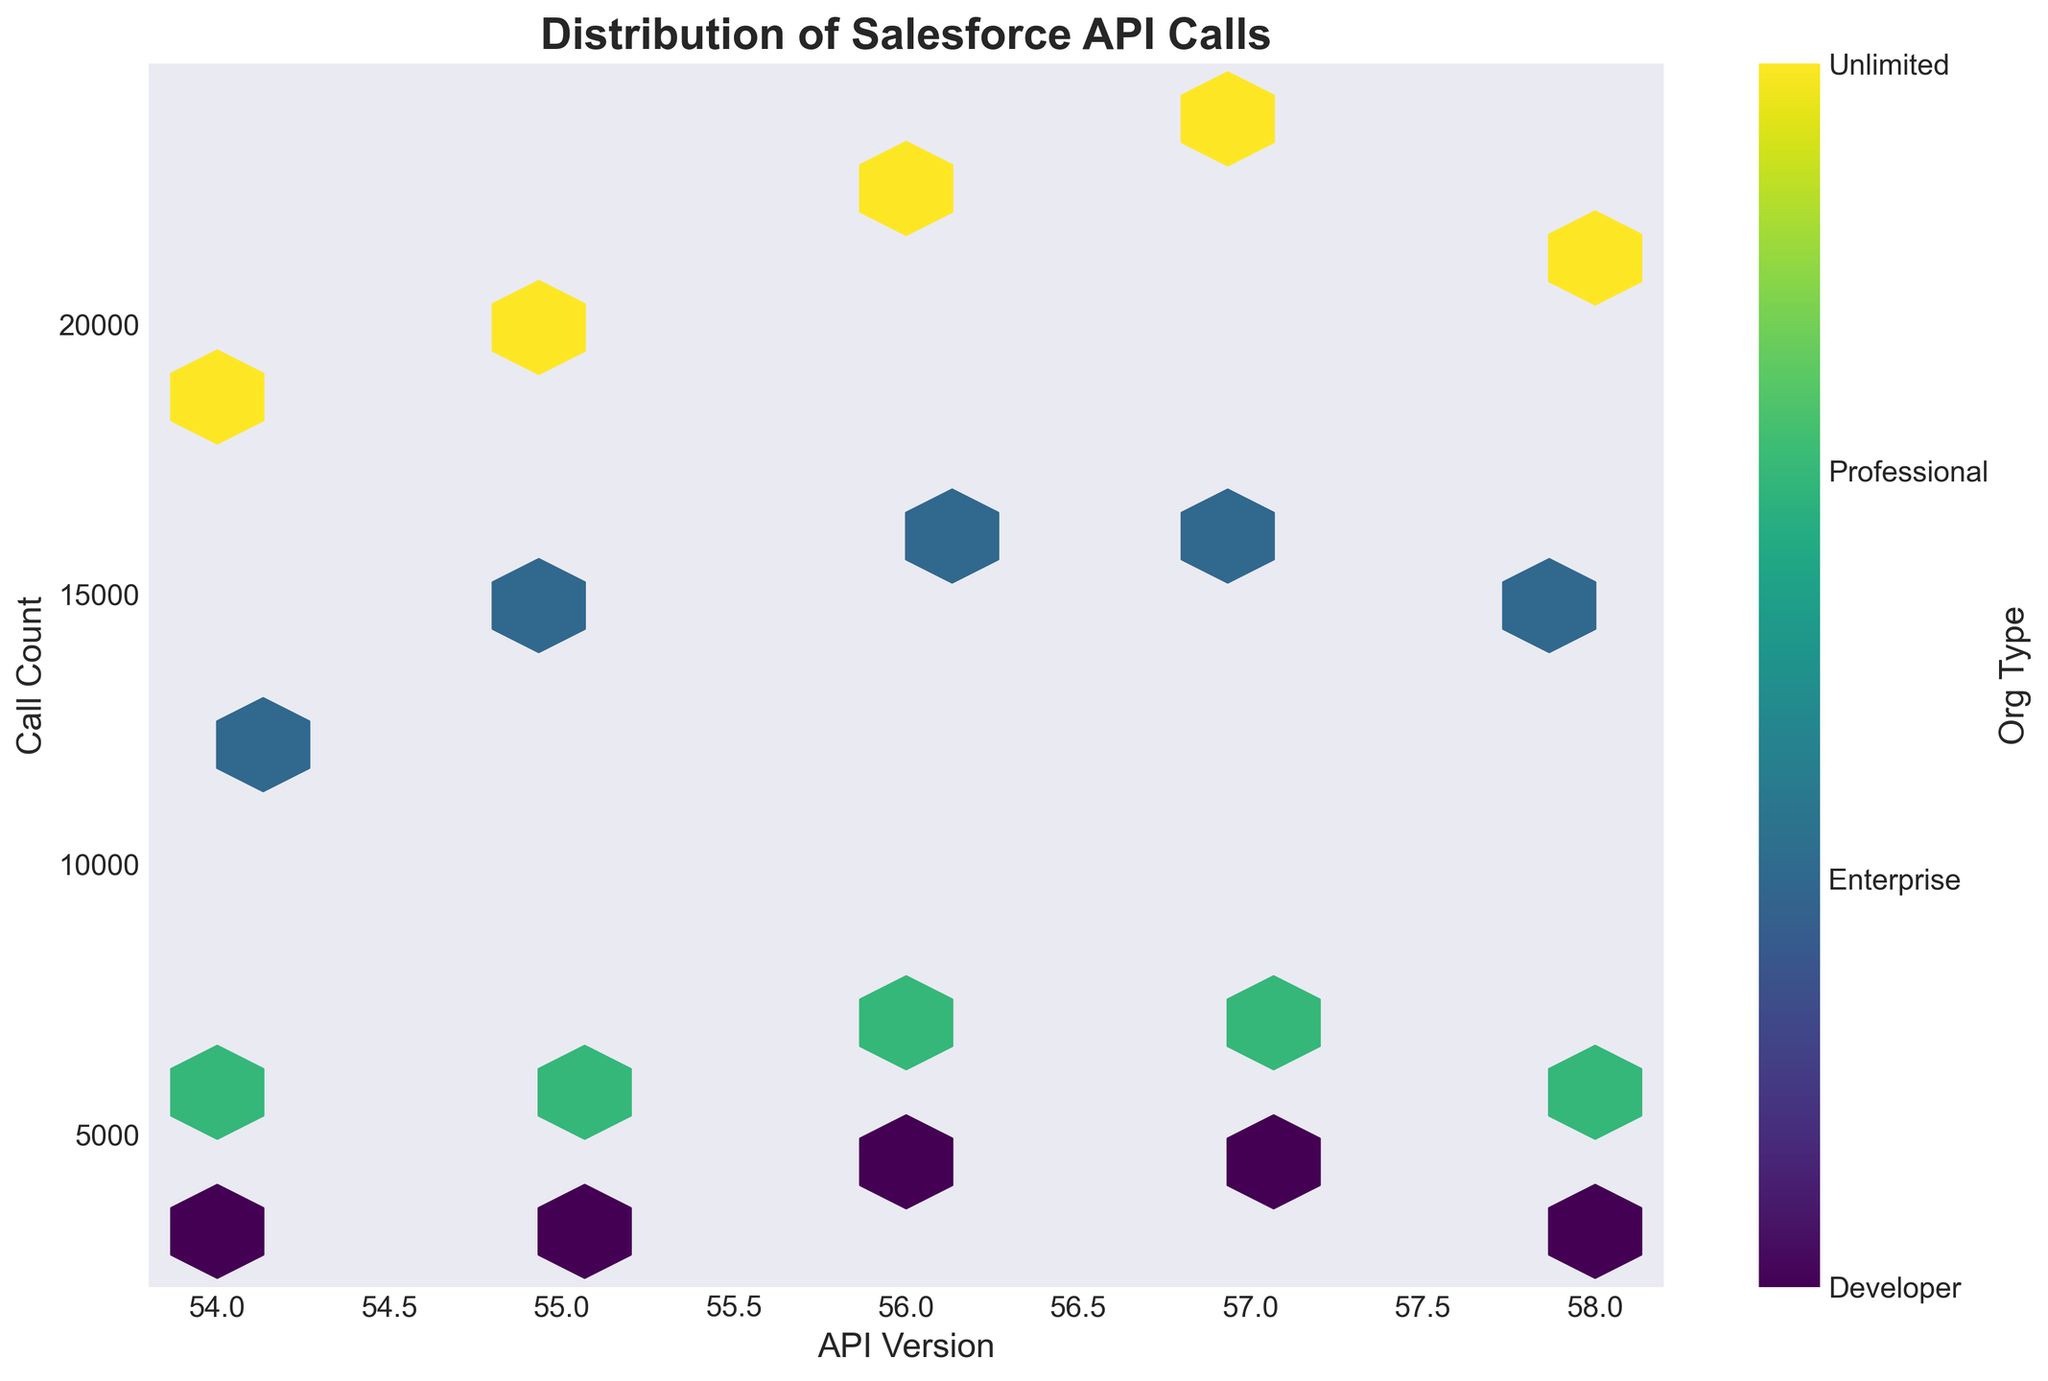What is the title of the plot? The title of the plot is typically located at the top center of the figure and provides a summary of the figure's purpose or information. In this plot, the title "Distribution of Salesforce API Calls" clarifies what is being visualized.
Answer: Distribution of Salesforce API Calls What are the labels for the x-axis and y-axis? Axis labels offer a description of what each axis represents. In this figure, the x-axis is labeled "API Version," indicating the different versions of the Salesforce API, while the y-axis is labeled "Call Count," representing the number of API calls.
Answer: API Version and Call Count How is the intensity or density of data represented in this plot? In a hexbin plot, the density of data points is shown by the coloring of the hexagons. The more data points that fall into a hexagon, the darker or more intense the color of that hexagon will be. This color intensity helps in visualizing areas with high or low data density.
Answer: By the color intensity of hexagons Which API version has the highest call count for the "Unlimited" Org Type? Look for the hexagon with the darkest color (representing the Unlimited Org Type) at its highest y-value (Call Count) along the x-axis (API Version).
Answer: 57.0 Is there a trend in the call count as the API version increases? To determine trends, observe the overall pattern of the hexagons across the x-axis (API Version). Increasing API versions should show whether the call counts tend to increase, decrease, or remain constant. The general pattern in the hexagon colors and positions indicates this trend.
Answer: Call count generally increases with API version Which Org Type accounts for the majority of API calls across all versions? By observing the color bar legend and matching the darkest or most frequent hexagons to their corresponding Org Types, we can deduce which Org Type has the highest number of API calls.
Answer: Unlimited Compare the hexbin density for API version 55.0 between Enterprise and Professional Org Types. Which one has a higher call count? Locate the hexagons aligned with API version 55.0, and compare the coloring or intensity of hexagons representing Enterprise and Professional Org Types. The darker hexagon indicates a higher call count.
Answer: Enterprise What is the median call count for API version 56.0? To determine the median call count, find the y-values (Call Counts) associated with API version 56.0. Since there are four different Org Types, list the call counts and find the middle value. If there are two middle values, average them. In this case, 15800 (Enterprise), 6900 (Professional), 4100 (Developer), and 22400 (Unlimited) are arranged as: 4100, 6900, 15800, 22400. متوسط 6900 و 15800 يساوي (6900 + 15800)/2 = 11350.
Answer: 11350 How does the distribution of API call counts for Developer Org change from version 54.0 to 58.0? Examine the configuration and color intensity of hexagons specifically for the Developer Org Type across API versions 54.0 to 58.0 along the x-axis and y-axis. Note if the hexagons move upwards or downwards in y-value (Call Count) and changes in their density or color intensity over this range.
Answer: Call count increases slightly from 3200 to 3900 What is the overall call count range for all Org Types in API version 57.0? Identify and extract the y-values (Call Counts) for all Org Types corresponding to API version 57.0, then determine the difference between the maximum and minimum call counts. The call counts are: Enterprise (16200), Professional (7100), Developer (4300), Unlimited (23800). The range is 23800 - 4300 = 19500.
Answer: 19500 